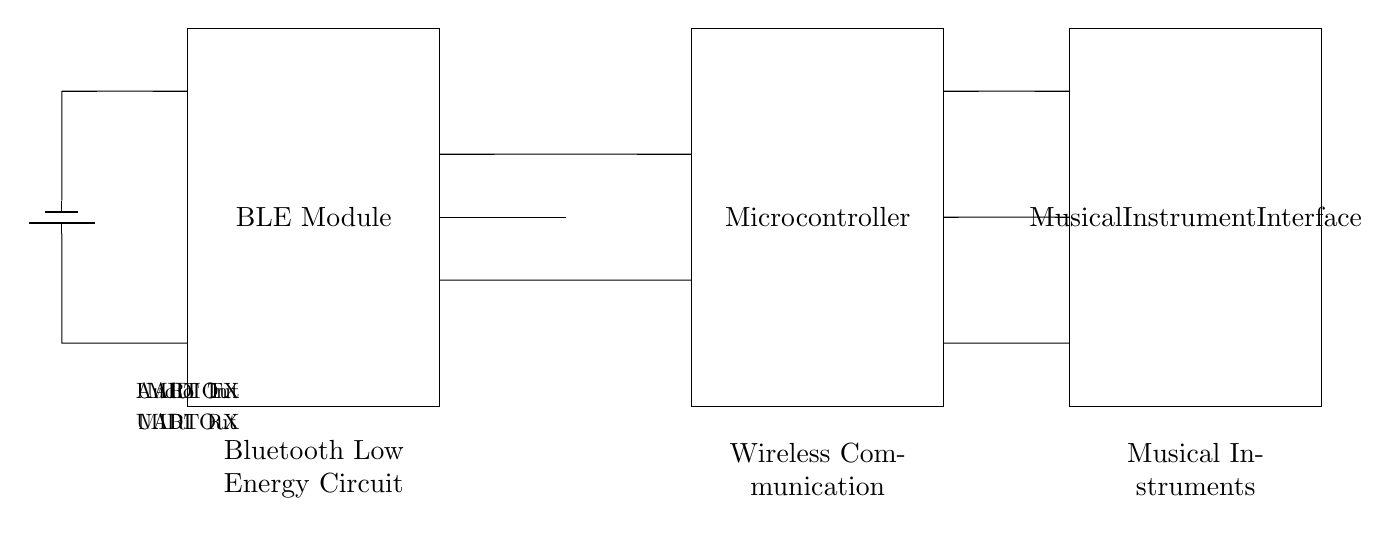What is the component representing wireless communication? The component representing wireless communication is labeled as the BLE Module, which is designated for Bluetooth Low Energy functionality.
Answer: BLE Module What is the power supply type used in this circuit? The power supply used in this circuit is a battery, specifically represented by the symbol for a battery in the diagram.
Answer: Battery How many connections are there from the BLE Module to the Microcontroller? There are two connections from the BLE Module to the Microcontroller, indicated as UART TX and UART RX.
Answer: Two What type of output does the Microcontroller provide to the Musical Instrument Interface? The Microcontroller provides Audio Out as an output to the Musical Instrument Interface, which is typically used for transmitting audio signals.
Answer: Audio Out What is the purpose of the MIDI In connection in this circuit? The MIDI In connection allows the Microcontroller to receive MIDI data from a musical instrument, facilitating communication for performance and composition.
Answer: Receive MIDI data Which component interfaces directly with musical instruments? The component that interfaces directly with musical instruments is the Musical Instrument Interface, which handles the audio and MIDI connections.
Answer: Musical Instrument Interface What is the direction of data flow between the Microcontroller and the Musical Instrument Interface for the MIDI Out connection? The direction of data flow for the MIDI Out connection is from the Microcontroller to the Musical Instrument Interface, indicating that musical note information is being sent out.
Answer: Microcontroller to Musical Instrument Interface 